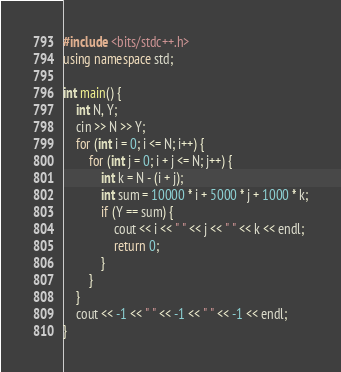<code> <loc_0><loc_0><loc_500><loc_500><_C++_>#include <bits/stdc++.h>
using namespace std;

int main() {
    int N, Y;
    cin >> N >> Y;
    for (int i = 0; i <= N; i++) {
        for (int j = 0; i + j <= N; j++) {
            int k = N - (i + j);
            int sum = 10000 * i + 5000 * j + 1000 * k;
            if (Y == sum) {
                cout << i << " " << j << " " << k << endl;
                return 0;
            }
        }
    }
    cout << -1 << " " << -1 << " " << -1 << endl;
}
</code> 